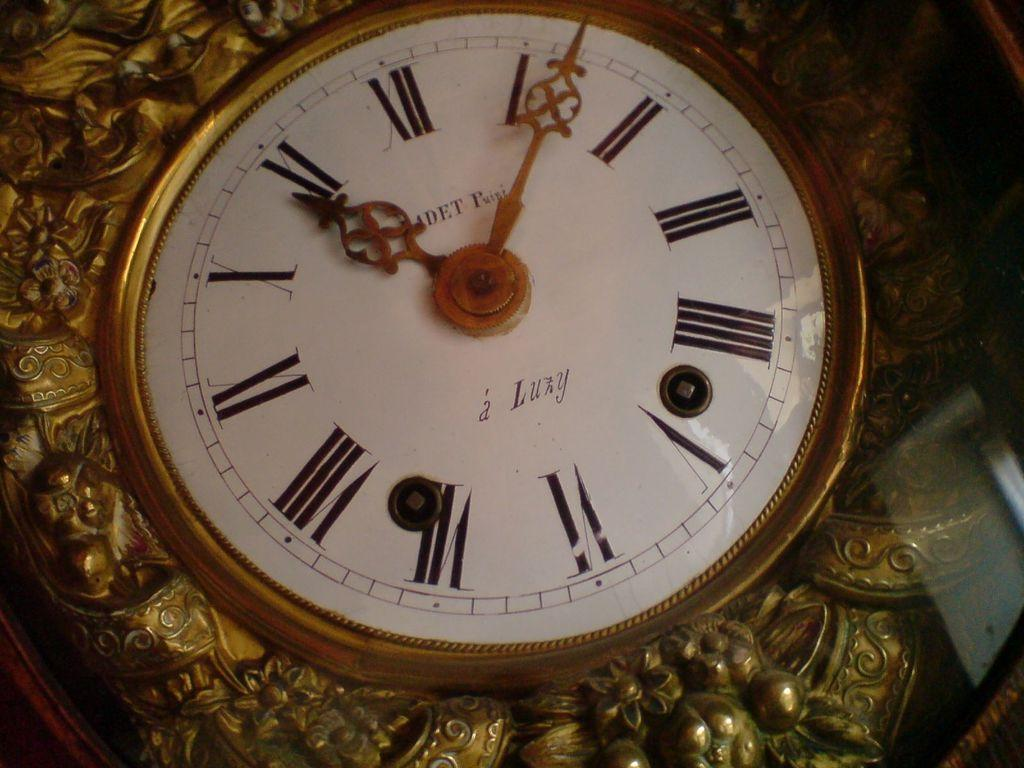<image>
Present a compact description of the photo's key features. An old gold clock points to the numbers II and 1 